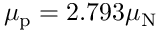<formula> <loc_0><loc_0><loc_500><loc_500>\mu _ { p } = 2 { . } 7 9 3 \mu _ { N }</formula> 